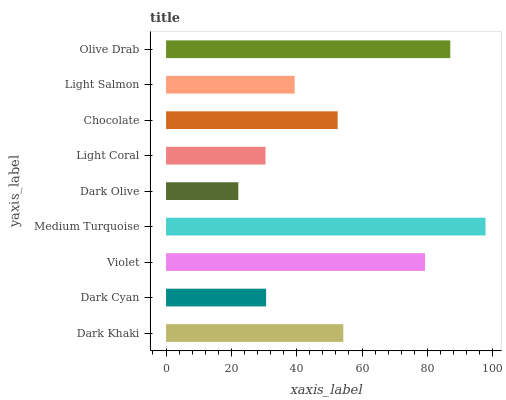Is Dark Olive the minimum?
Answer yes or no. Yes. Is Medium Turquoise the maximum?
Answer yes or no. Yes. Is Dark Cyan the minimum?
Answer yes or no. No. Is Dark Cyan the maximum?
Answer yes or no. No. Is Dark Khaki greater than Dark Cyan?
Answer yes or no. Yes. Is Dark Cyan less than Dark Khaki?
Answer yes or no. Yes. Is Dark Cyan greater than Dark Khaki?
Answer yes or no. No. Is Dark Khaki less than Dark Cyan?
Answer yes or no. No. Is Chocolate the high median?
Answer yes or no. Yes. Is Chocolate the low median?
Answer yes or no. Yes. Is Violet the high median?
Answer yes or no. No. Is Light Salmon the low median?
Answer yes or no. No. 